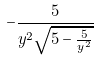Convert formula to latex. <formula><loc_0><loc_0><loc_500><loc_500>- \frac { 5 } { y ^ { 2 } \sqrt { 5 - \frac { 5 } { y ^ { 2 } } } }</formula> 